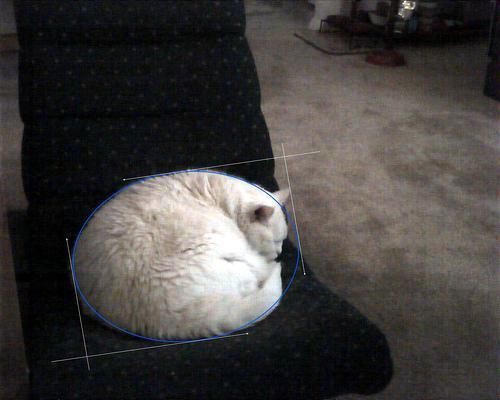How many cats are visible in the picture?
Give a very brief answer. 1. 